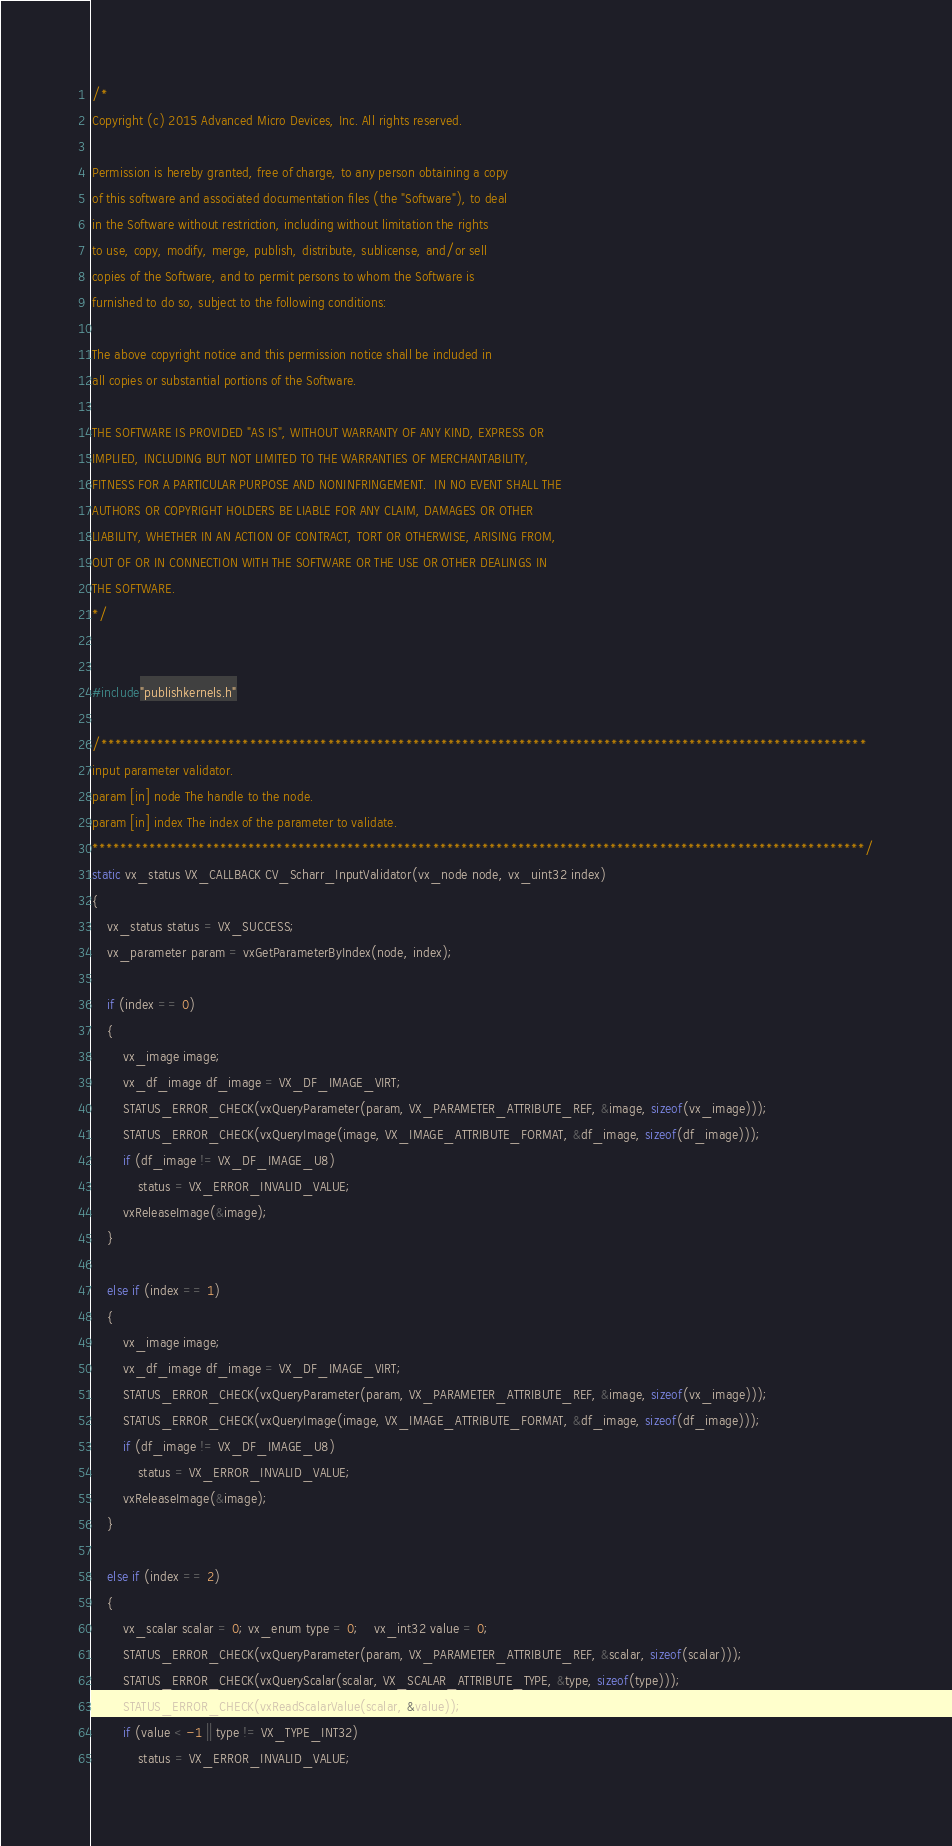<code> <loc_0><loc_0><loc_500><loc_500><_C++_>/* 
Copyright (c) 2015 Advanced Micro Devices, Inc. All rights reserved.
 
Permission is hereby granted, free of charge, to any person obtaining a copy
of this software and associated documentation files (the "Software"), to deal
in the Software without restriction, including without limitation the rights
to use, copy, modify, merge, publish, distribute, sublicense, and/or sell
copies of the Software, and to permit persons to whom the Software is
furnished to do so, subject to the following conditions:
 
The above copyright notice and this permission notice shall be included in
all copies or substantial portions of the Software.
 
THE SOFTWARE IS PROVIDED "AS IS", WITHOUT WARRANTY OF ANY KIND, EXPRESS OR
IMPLIED, INCLUDING BUT NOT LIMITED TO THE WARRANTIES OF MERCHANTABILITY,
FITNESS FOR A PARTICULAR PURPOSE AND NONINFRINGEMENT.  IN NO EVENT SHALL THE
AUTHORS OR COPYRIGHT HOLDERS BE LIABLE FOR ANY CLAIM, DAMAGES OR OTHER
LIABILITY, WHETHER IN AN ACTION OF CONTRACT, TORT OR OTHERWISE, ARISING FROM,
OUT OF OR IN CONNECTION WITH THE SOFTWARE OR THE USE OR OTHER DEALINGS IN
THE SOFTWARE.
*/


#include"publishkernels.h"

/************************************************************************************************************
input parameter validator.
param [in] node The handle to the node.
param [in] index The index of the parameter to validate.
*************************************************************************************************************/
static vx_status VX_CALLBACK CV_Scharr_InputValidator(vx_node node, vx_uint32 index)
{
	vx_status status = VX_SUCCESS;
	vx_parameter param = vxGetParameterByIndex(node, index);

	if (index == 0)
	{
		vx_image image;
		vx_df_image df_image = VX_DF_IMAGE_VIRT;
		STATUS_ERROR_CHECK(vxQueryParameter(param, VX_PARAMETER_ATTRIBUTE_REF, &image, sizeof(vx_image)));
		STATUS_ERROR_CHECK(vxQueryImage(image, VX_IMAGE_ATTRIBUTE_FORMAT, &df_image, sizeof(df_image)));
		if (df_image != VX_DF_IMAGE_U8)
			status = VX_ERROR_INVALID_VALUE;
		vxReleaseImage(&image);
	}

	else if (index == 1)
	{
		vx_image image;
		vx_df_image df_image = VX_DF_IMAGE_VIRT;
		STATUS_ERROR_CHECK(vxQueryParameter(param, VX_PARAMETER_ATTRIBUTE_REF, &image, sizeof(vx_image)));
		STATUS_ERROR_CHECK(vxQueryImage(image, VX_IMAGE_ATTRIBUTE_FORMAT, &df_image, sizeof(df_image)));
		if (df_image != VX_DF_IMAGE_U8)
			status = VX_ERROR_INVALID_VALUE;
		vxReleaseImage(&image);
	}

	else if (index == 2)
	{
		vx_scalar scalar = 0; vx_enum type = 0;	vx_int32 value = 0;
		STATUS_ERROR_CHECK(vxQueryParameter(param, VX_PARAMETER_ATTRIBUTE_REF, &scalar, sizeof(scalar)));
		STATUS_ERROR_CHECK(vxQueryScalar(scalar, VX_SCALAR_ATTRIBUTE_TYPE, &type, sizeof(type)));
		STATUS_ERROR_CHECK(vxReadScalarValue(scalar, &value));
		if (value < -1 || type != VX_TYPE_INT32)
			status = VX_ERROR_INVALID_VALUE;</code> 